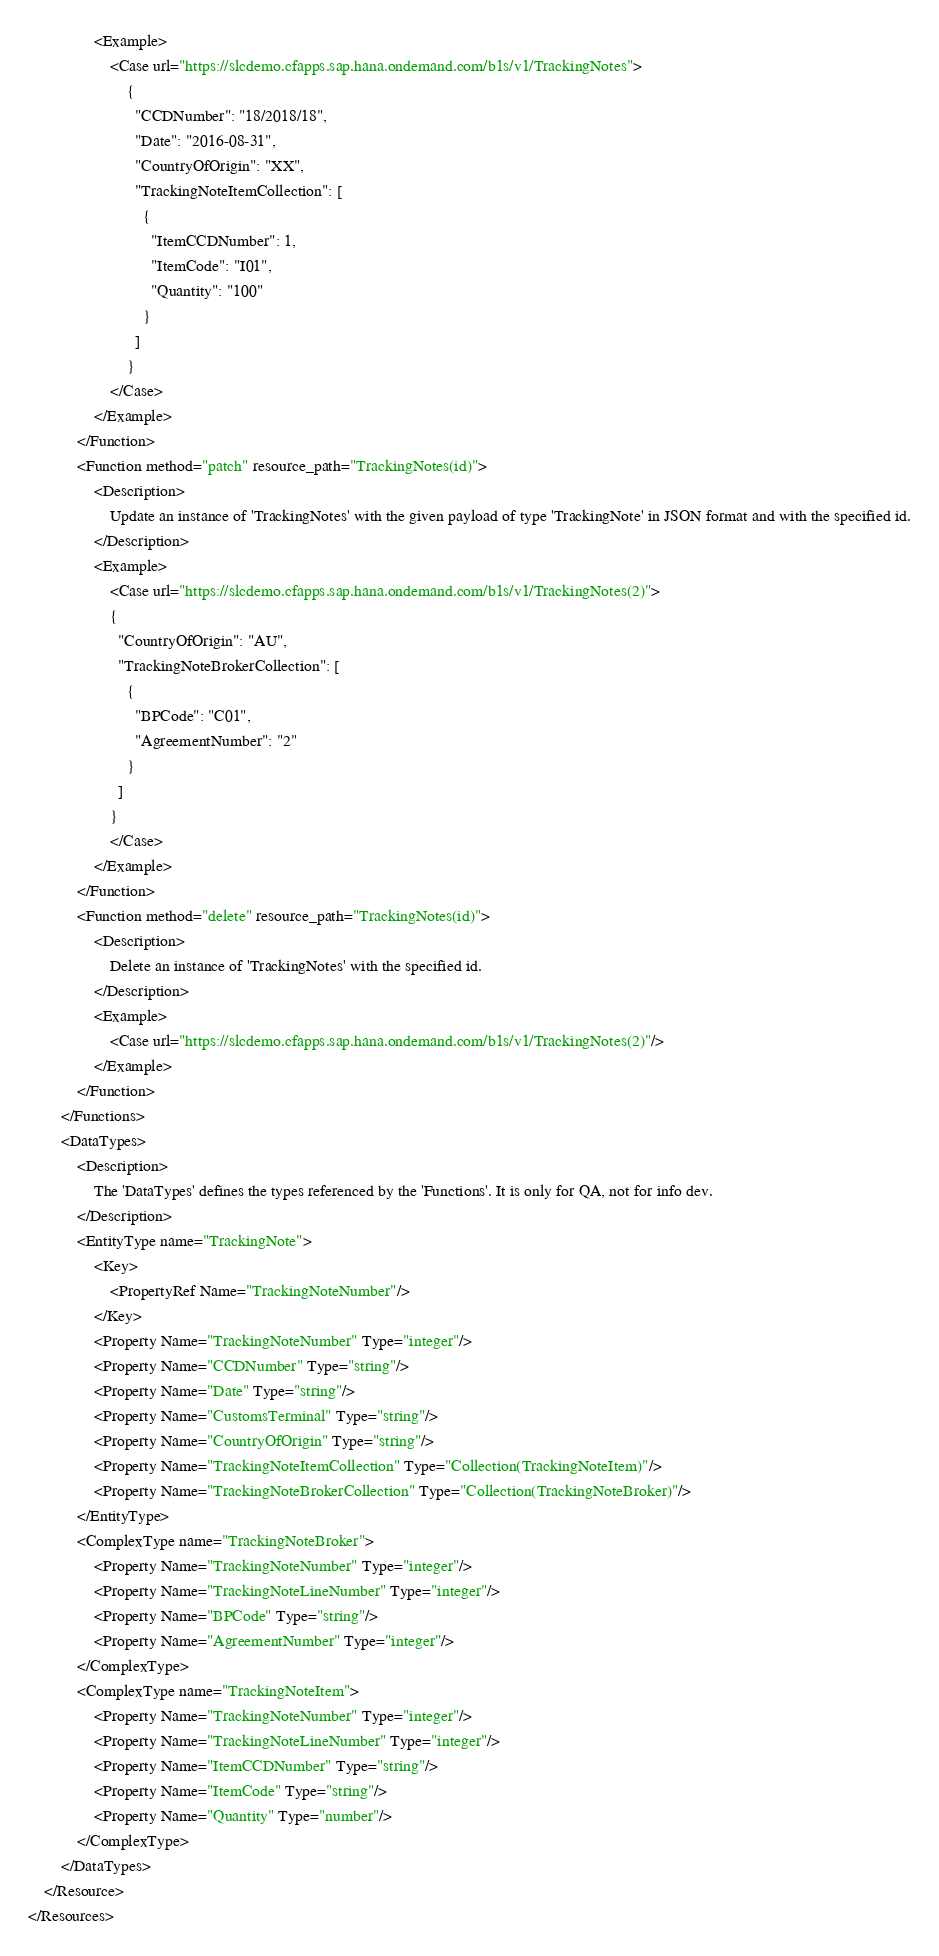<code> <loc_0><loc_0><loc_500><loc_500><_XML_>				<Example>
					<Case url="https://slcdemo.cfapps.sap.hana.ondemand.com/b1s/v1/TrackingNotes">
						{
						  "CCDNumber": "18/2018/18",
						  "Date": "2016-08-31",
						  "CountryOfOrigin": "XX",
						  "TrackingNoteItemCollection": [
							{
							  "ItemCCDNumber": 1,
							  "ItemCode": "I01",
							  "Quantity": "100"
							}
						  ]
						}
					</Case>
				</Example>
			</Function>
			<Function method="patch" resource_path="TrackingNotes(id)">
				<Description>
					Update an instance of 'TrackingNotes' with the given payload of type 'TrackingNote' in JSON format and with the specified id.
				</Description>
				<Example>
					<Case url="https://slcdemo.cfapps.sap.hana.ondemand.com/b1s/v1/TrackingNotes(2)">
					{
					  "CountryOfOrigin": "AU",
					  "TrackingNoteBrokerCollection": [
						{
						  "BPCode": "C01",
						  "AgreementNumber": "2"
						}
					  ]
					}
					</Case>
				</Example>
			</Function>
			<Function method="delete" resource_path="TrackingNotes(id)">
				<Description>
					Delete an instance of 'TrackingNotes' with the specified id.
				</Description>
				<Example>
					<Case url="https://slcdemo.cfapps.sap.hana.ondemand.com/b1s/v1/TrackingNotes(2)"/>
				</Example>
			</Function>
		</Functions>
		<DataTypes>
			<Description>
				The 'DataTypes' defines the types referenced by the 'Functions'. It is only for QA, not for info dev.
			</Description>
			<EntityType name="TrackingNote">
				<Key>
					<PropertyRef Name="TrackingNoteNumber"/>
				</Key>
				<Property Name="TrackingNoteNumber" Type="integer"/>
				<Property Name="CCDNumber" Type="string"/>
				<Property Name="Date" Type="string"/>
				<Property Name="CustomsTerminal" Type="string"/>
				<Property Name="CountryOfOrigin" Type="string"/>
				<Property Name="TrackingNoteItemCollection" Type="Collection(TrackingNoteItem)"/>
				<Property Name="TrackingNoteBrokerCollection" Type="Collection(TrackingNoteBroker)"/>
			</EntityType>
			<ComplexType name="TrackingNoteBroker">
				<Property Name="TrackingNoteNumber" Type="integer"/>
				<Property Name="TrackingNoteLineNumber" Type="integer"/>
				<Property Name="BPCode" Type="string"/>
				<Property Name="AgreementNumber" Type="integer"/>
			</ComplexType>
			<ComplexType name="TrackingNoteItem">
				<Property Name="TrackingNoteNumber" Type="integer"/>
				<Property Name="TrackingNoteLineNumber" Type="integer"/>
				<Property Name="ItemCCDNumber" Type="string"/>
				<Property Name="ItemCode" Type="string"/>
				<Property Name="Quantity" Type="number"/>
			</ComplexType>
		</DataTypes>
	</Resource>
</Resources>
</code> 